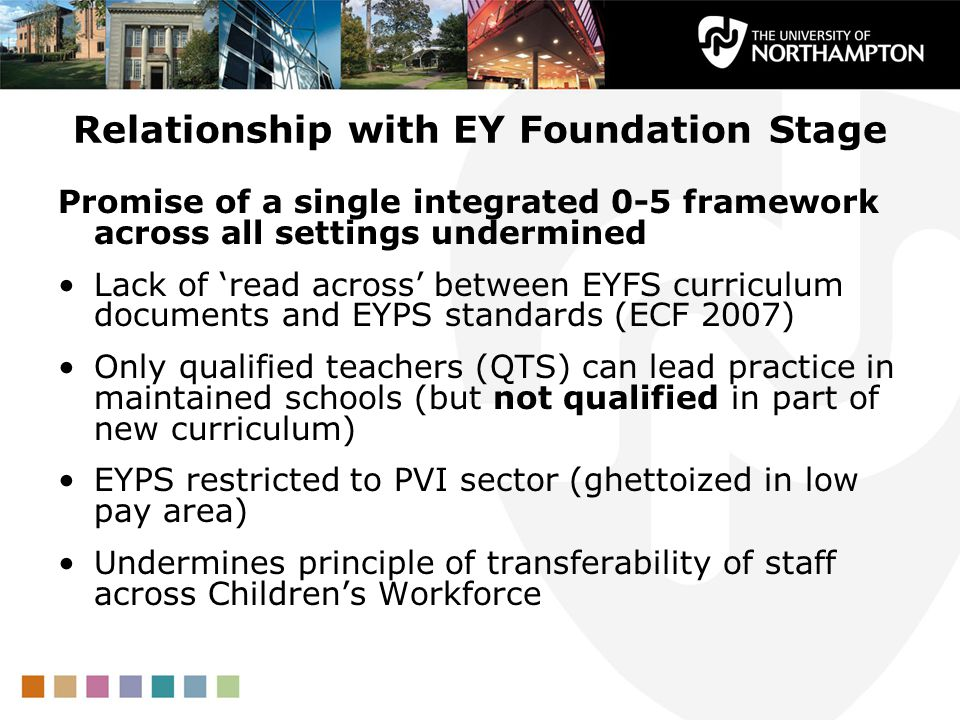Considering the issues raised in the bullet points about the integration and qualifications within the EY Foundation Stage, what might be the potential implications for staff mobility and quality of education within the EYFS framework, based on the information provided on the slide? Based on the information provided on the slide, the potential implications for staff mobility could involve challenges in maintaining a consistent educational approach across various settings. This is due to the undermined promise of a single integrated framework, as highlighted by the lack of alignment between the EYFS curriculum documents and EYPS standards. Additionally, the restriction of EYPS to the PVI sector, particularly in low-paying areas, may limit the mobility of qualified staff to better-compensated roles, potentially leading to difficulties in retaining skilled educators. In terms of educational quality, the absence of necessary qualifications in parts of the new curriculum for teachers suggests possible gaps in the ability of educators to effectively deliver the EYFS curriculum. These gaps may impact the overall quality of education provided within the framework. 